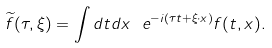Convert formula to latex. <formula><loc_0><loc_0><loc_500><loc_500>\widetilde { f } ( \tau , \xi ) = \int d t d x \ e ^ { - i ( \tau t + \xi \cdot x ) } f ( t , x ) .</formula> 